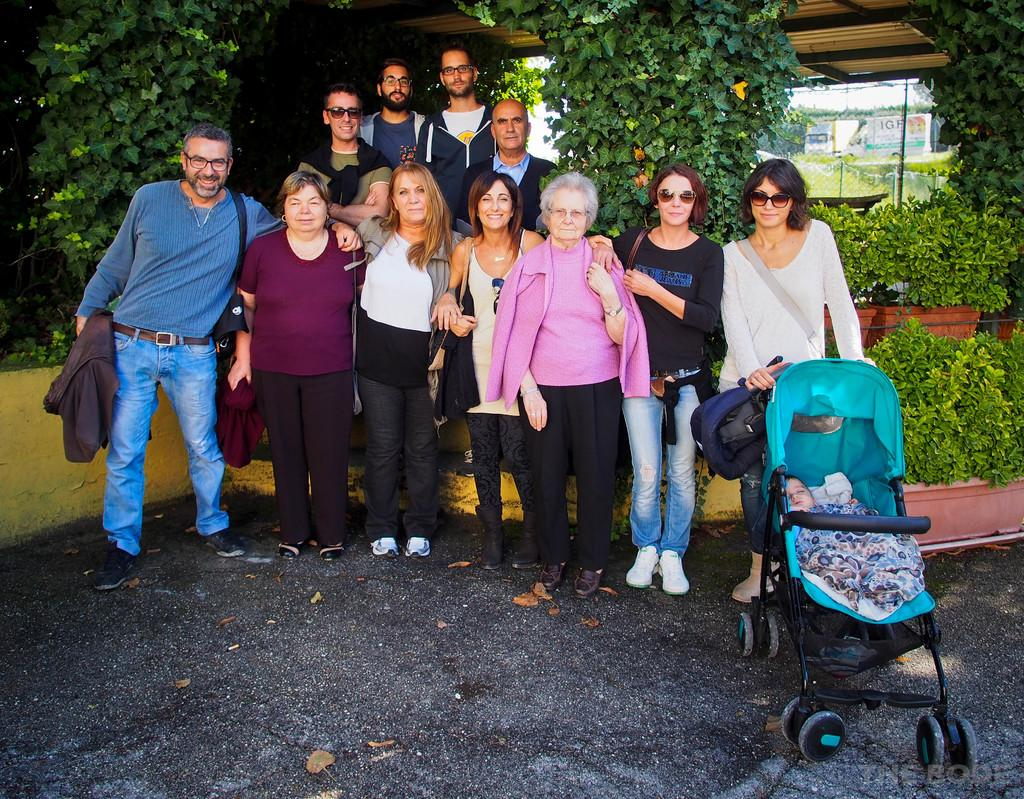How many people are in the image? There is a group of people in the image. What is one specific item visible in the image? There is a wheelchair in the image. What type of vegetation can be seen in the image? There are plants and trees in the image. What can be seen in the background of the image? There are houses in the background of the image. What type of rice is being served to the beggar in the image? There is no beggar or rice present in the image. Who is the uncle in the image? There is no uncle mentioned or depicted in the image. 